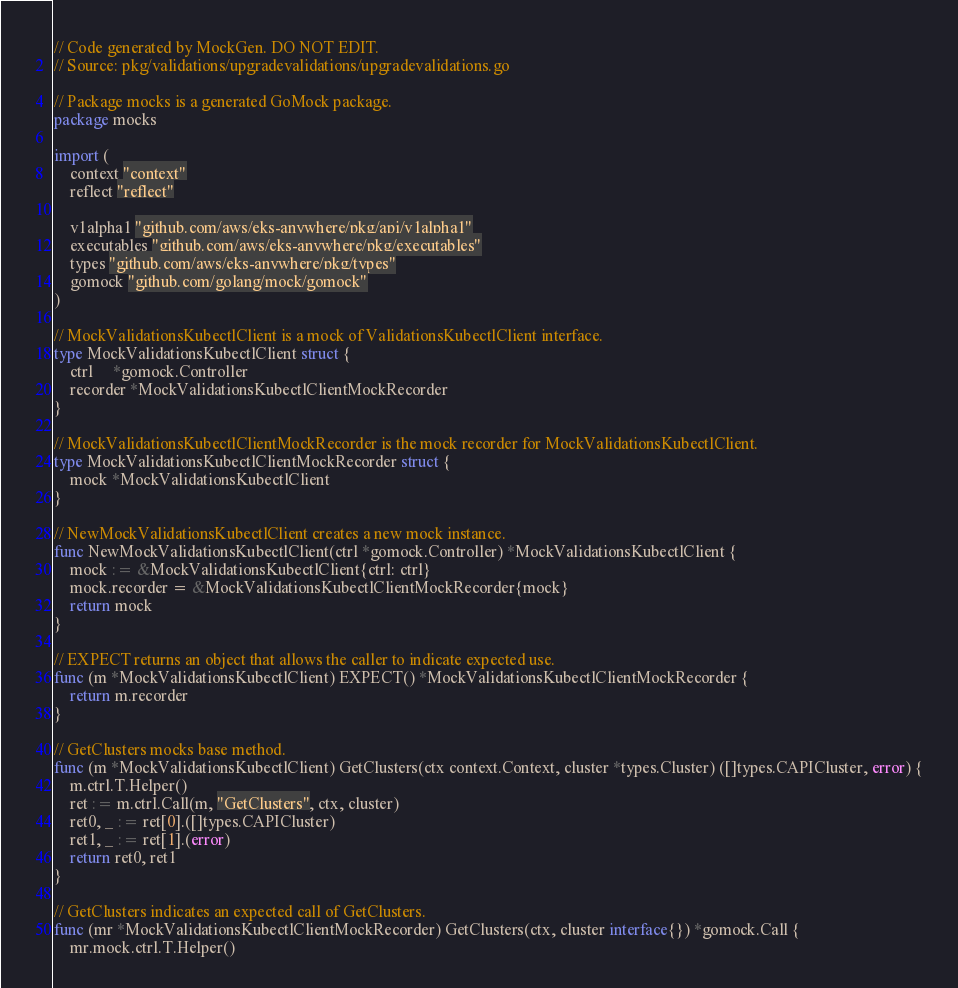<code> <loc_0><loc_0><loc_500><loc_500><_Go_>// Code generated by MockGen. DO NOT EDIT.
// Source: pkg/validations/upgradevalidations/upgradevalidations.go

// Package mocks is a generated GoMock package.
package mocks

import (
	context "context"
	reflect "reflect"

	v1alpha1 "github.com/aws/eks-anywhere/pkg/api/v1alpha1"
	executables "github.com/aws/eks-anywhere/pkg/executables"
	types "github.com/aws/eks-anywhere/pkg/types"
	gomock "github.com/golang/mock/gomock"
)

// MockValidationsKubectlClient is a mock of ValidationsKubectlClient interface.
type MockValidationsKubectlClient struct {
	ctrl     *gomock.Controller
	recorder *MockValidationsKubectlClientMockRecorder
}

// MockValidationsKubectlClientMockRecorder is the mock recorder for MockValidationsKubectlClient.
type MockValidationsKubectlClientMockRecorder struct {
	mock *MockValidationsKubectlClient
}

// NewMockValidationsKubectlClient creates a new mock instance.
func NewMockValidationsKubectlClient(ctrl *gomock.Controller) *MockValidationsKubectlClient {
	mock := &MockValidationsKubectlClient{ctrl: ctrl}
	mock.recorder = &MockValidationsKubectlClientMockRecorder{mock}
	return mock
}

// EXPECT returns an object that allows the caller to indicate expected use.
func (m *MockValidationsKubectlClient) EXPECT() *MockValidationsKubectlClientMockRecorder {
	return m.recorder
}

// GetClusters mocks base method.
func (m *MockValidationsKubectlClient) GetClusters(ctx context.Context, cluster *types.Cluster) ([]types.CAPICluster, error) {
	m.ctrl.T.Helper()
	ret := m.ctrl.Call(m, "GetClusters", ctx, cluster)
	ret0, _ := ret[0].([]types.CAPICluster)
	ret1, _ := ret[1].(error)
	return ret0, ret1
}

// GetClusters indicates an expected call of GetClusters.
func (mr *MockValidationsKubectlClientMockRecorder) GetClusters(ctx, cluster interface{}) *gomock.Call {
	mr.mock.ctrl.T.Helper()</code> 